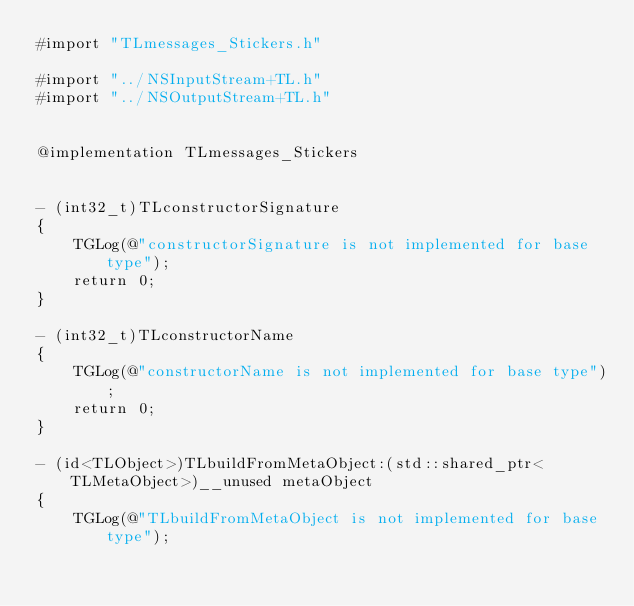Convert code to text. <code><loc_0><loc_0><loc_500><loc_500><_ObjectiveC_>#import "TLmessages_Stickers.h"

#import "../NSInputStream+TL.h"
#import "../NSOutputStream+TL.h"


@implementation TLmessages_Stickers


- (int32_t)TLconstructorSignature
{
    TGLog(@"constructorSignature is not implemented for base type");
    return 0;
}

- (int32_t)TLconstructorName
{
    TGLog(@"constructorName is not implemented for base type");
    return 0;
}

- (id<TLObject>)TLbuildFromMetaObject:(std::shared_ptr<TLMetaObject>)__unused metaObject
{
    TGLog(@"TLbuildFromMetaObject is not implemented for base type");</code> 